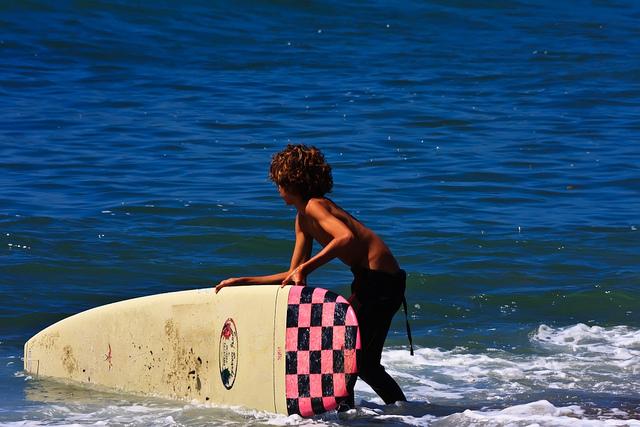Is the boy wearing a shirt?
Quick response, please. No. Is this an overcast day?
Be succinct. No. How many people are in the water?
Keep it brief. 1. What is the man holding?
Be succinct. Surfboard. What color is the end of the surfboard?
Answer briefly. Pink and black. 